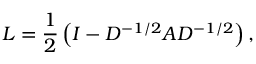Convert formula to latex. <formula><loc_0><loc_0><loc_500><loc_500>L = \frac { 1 } { 2 } \left ( I - D ^ { - 1 / 2 } A D ^ { - 1 / 2 } \right ) ,</formula> 